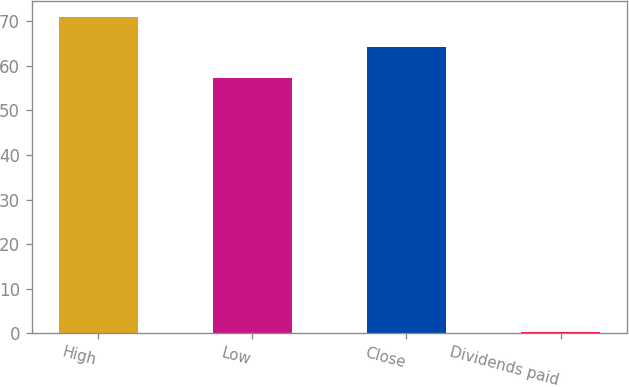<chart> <loc_0><loc_0><loc_500><loc_500><bar_chart><fcel>High<fcel>Low<fcel>Close<fcel>Dividends paid<nl><fcel>70.91<fcel>57.2<fcel>64.24<fcel>0.34<nl></chart> 